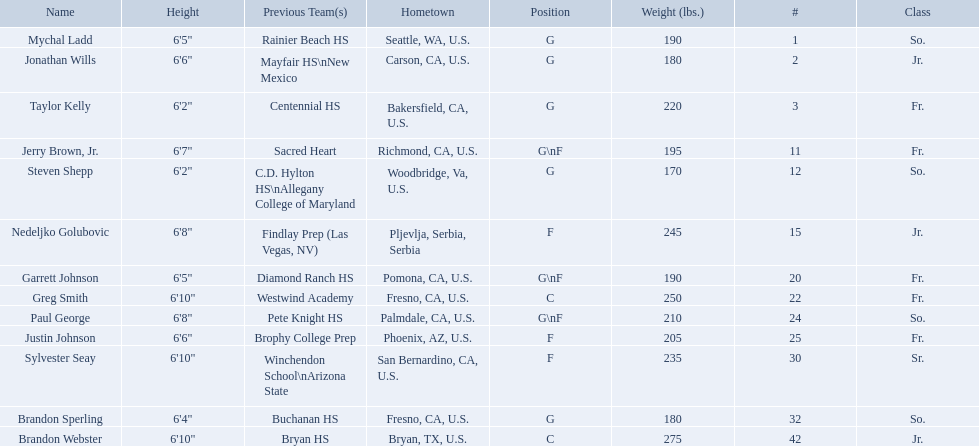Which positions are so.? G, G, G\nF, G. Which weights are g 190, 170, 180. What height is under 6 3' 6'2". What is the name Steven Shepp. 